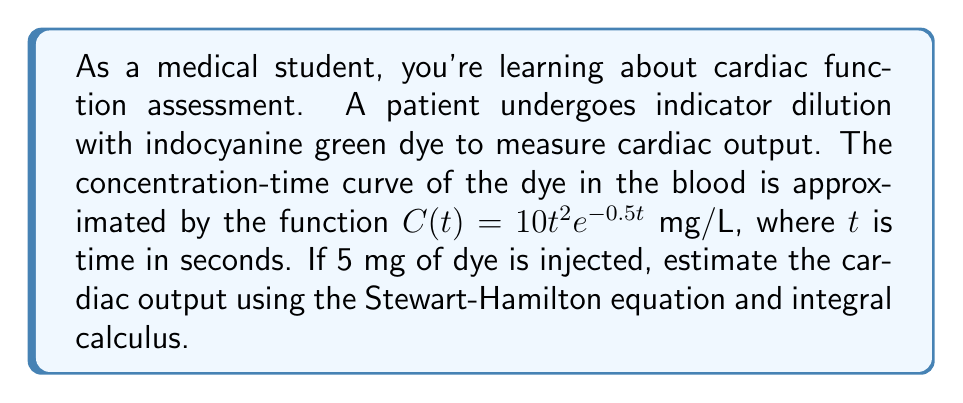Could you help me with this problem? 1) The Stewart-Hamilton equation for cardiac output (CO) is:

   $$CO = \frac{m}{\int_0^\infty C(t) dt}$$

   Where $m$ is the amount of indicator injected, and $C(t)$ is the concentration-time curve.

2) We're given $m = 5$ mg and $C(t) = 10t^2e^{-0.5t}$ mg/L.

3) To solve this, we need to evaluate the integral $\int_0^\infty 10t^2e^{-0.5t} dt$.

4) This integral can be solved using integration by parts twice:

   Let $u = t^2$ and $dv = e^{-0.5t}dt$
   Then $du = 2t dt$ and $v = -2e^{-0.5t}$

   $$\int t^2e^{-0.5t} dt = -2t^2e^{-0.5t} + \int 4te^{-0.5t} dt$$

   Now for the remaining integral, let $u = t$ and $dv = e^{-0.5t}dt$
   Then $du = dt$ and $v = -2e^{-0.5t}$

   $$\int 4te^{-0.5t} dt = -8te^{-0.5t} + \int 8e^{-0.5t} dt = -8te^{-0.5t} - 16e^{-0.5t} + C$$

5) Putting it all together:

   $$\int t^2e^{-0.5t} dt = -2t^2e^{-0.5t} - 8te^{-0.5t} - 16e^{-0.5t} + C$$

6) Evaluating from 0 to infinity:

   $$\lim_{t \to \infty} (-2t^2e^{-0.5t} - 8te^{-0.5t} - 16e^{-0.5t}) - (-2(0)^2e^{-0.5(0)} - 8(0)e^{-0.5(0)} - 16e^{-0.5(0)})$$
   $$= 0 - (-16) = 16$$

7) Therefore, $\int_0^\infty 10t^2e^{-0.5t} dt = 10 * 16 = 160$

8) Plugging this into the Stewart-Hamilton equation:

   $$CO = \frac{5}{160} = 0.03125 \text{ L/s} = 1.875 \text{ L/min}$$
Answer: 1.875 L/min 